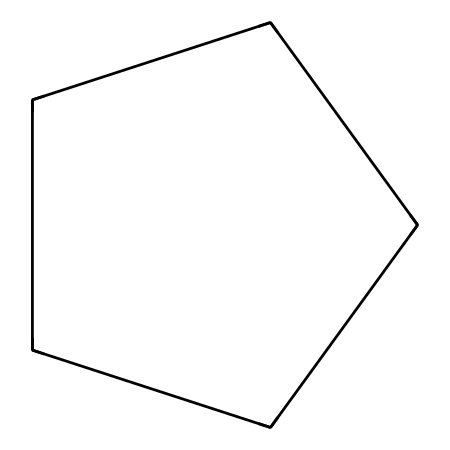How many carbon atoms are in cyclopentane? The SMILES representation shows "C1CCCC1," indicating there are five carbon atoms that form a closed ring (the "1" signifies the start and end of the cyclic structure).
Answer: five What type of chemical structure is represented by this SMILES? The prefix "cyclo" in cyclopentane refers to a cyclic structure, resulting in a ring formation of the carbon atoms. Cyclopentane is specifically a cycloalkane, which is characterized by carbon atoms connected in a ring.
Answer: cycloalkane What is the degree of unsaturation in cyclopentane? The formula for calculating the degree of unsaturation (DU) is (2C + 2 - H)/2. For cyclopentane with five carbons (C=5, H=10), the DU equals (2(5) + 2 - 10)/2 = 0, indicating no unsaturation.
Answer: zero What is the bond angle around each carbon in cyclopentane? In cyclopentane, each carbon atom is tetrahedrally coordinated to two other carbons and two hydrogens, giving rise to bond angles near 109.5 degrees.
Answer: approximately 109.5 degrees What is one of the main uses of cyclopentane in industry? Cyclopentane is often used as a blowing agent in the production of foam, particularly in polyurethane. Its low boiling point and favorable properties make it suitable for this application.
Answer: blowing agent How does the cyclical structure of cyclopentane affect its physical properties compared to linear alkanes? The cyclic structure of cyclopentane contributes to a higher boiling point compared to its straight-chain counterparts, primarily due to the ring strain and the compact arrangement of atoms, which increases molecular interactions.
Answer: higher boiling point What type of fuel additive category does cyclopentane fall under? Cyclopentane is recognized as a type of aliphatic hydrocarbon, and it is considered a fuel additive due to its properties that may enhance combustion efficiency in certain applications.
Answer: aliphatic hydrocarbon 